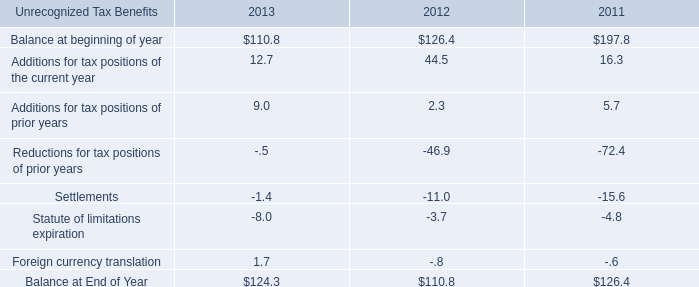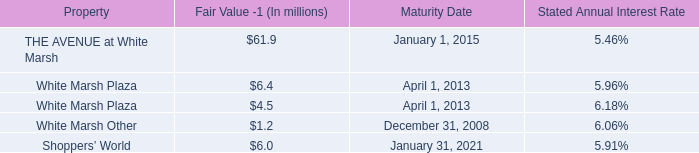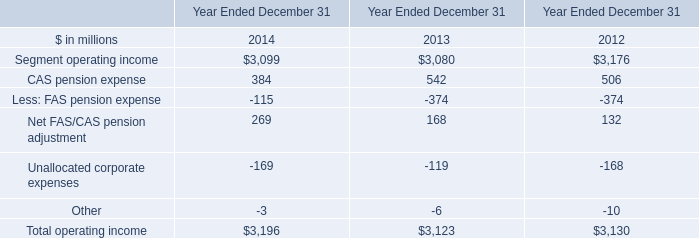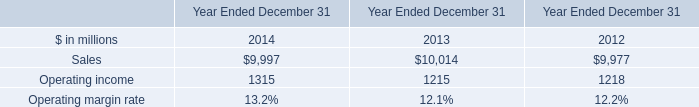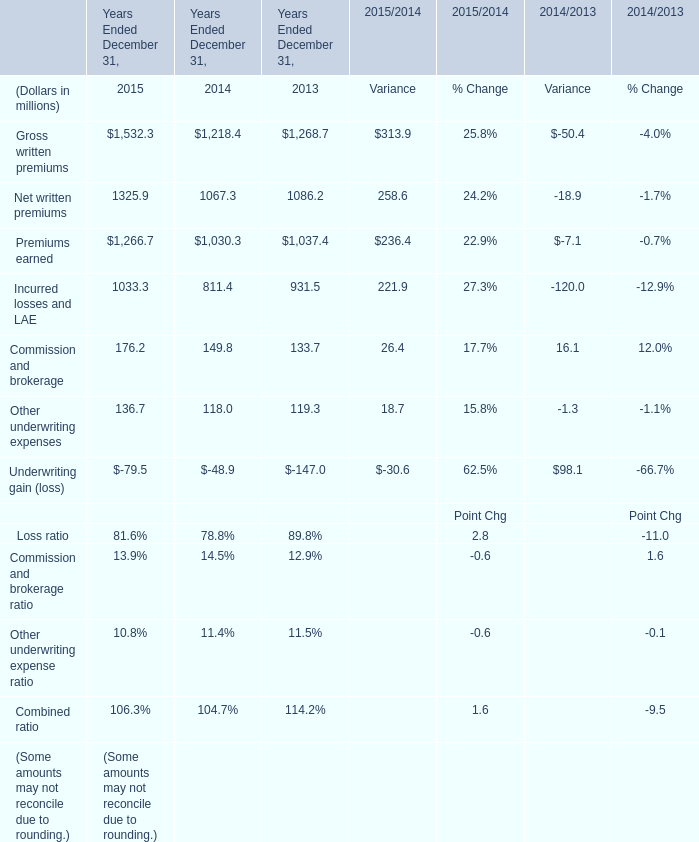What was the average value of the Premiums earned in the years where Gross written premiums is positive? (in million) 
Computations: (((1266.7 + 1030.3) + 1037.4) / 3)
Answer: 1111.46667. 